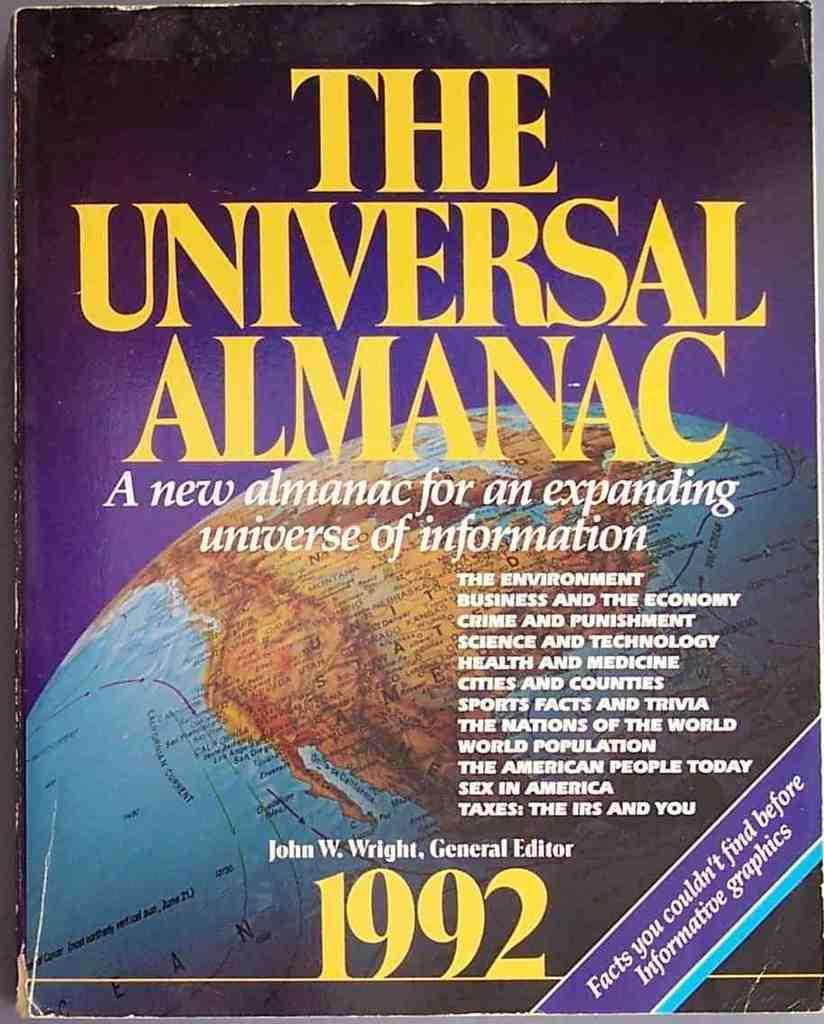In one or two sentences, can you explain what this image depicts? in this image we can see a cover of a book with some text and some numbers on it. 